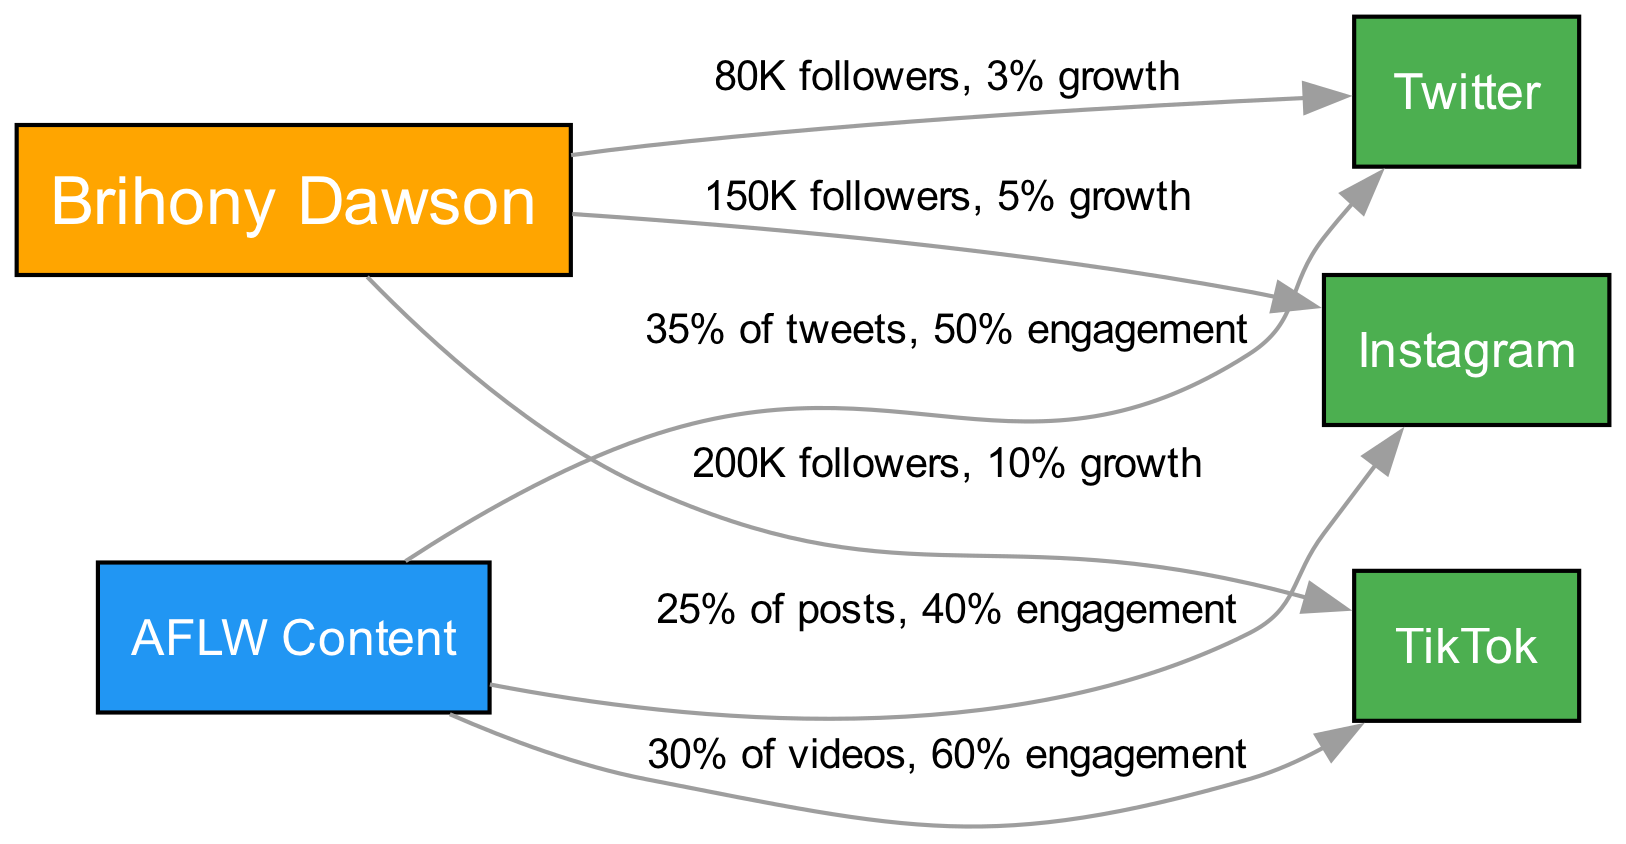What is Brihony Dawson's follower count on Instagram? The edge connecting Brihony Dawson to Instagram indicates "150K followers," which directly states the follower count for this platform.
Answer: 150K followers What is the engagement rate for AFLW content on TikTok? The edge connecting AFLW Content to TikTok shows "30% of videos, 60% engagement," indicating that the engagement rate for related content on TikTok is 60%.
Answer: 60% Which social media platform has the highest growth percentage? The edges show growth rates of 5% for Instagram, 3% for Twitter, and 10% for TikTok. Comparing these rates, TikTok has the highest growth rate at 10%.
Answer: 10% What percentage of tweets comes from AFLW content? The edge connecting AFLW Content to Twitter specifies "35% of tweets," indicating the proportion of tweets related to AFLW content.
Answer: 35% How many platforms are represented in the diagram? The diagram lists three platforms: Instagram, Twitter, and TikTok. By counting each unique platform node, there are a total of three.
Answer: 3 Which platform has the lowest follower count according to the diagram? The follower counts are 150K for Instagram, 80K for Twitter, and 200K for TikTok. Since Twitter has 80K followers, it is the platform with the lowest follower count.
Answer: 80K followers What type of content has the highest engagement on TikTok? The edge from AFLW Content to TikTok states "30% of videos, 60% engagement," showcasing that AFLW-related videos have the highest engagement on TikTok at 60%.
Answer: AFLW Content How many total edges are in the diagram? By examining the connections (edges) listed, there are a total of six labeled relationships between the nodes, which indicates six edges in the diagram.
Answer: 6 What content category has the highest engagement rate on Twitter? The relationship from AFLW Content to Twitter indicates a 50% engagement rate. As it is the only content category specified for Twitter, it has the highest engagement rate there.
Answer: 50% 